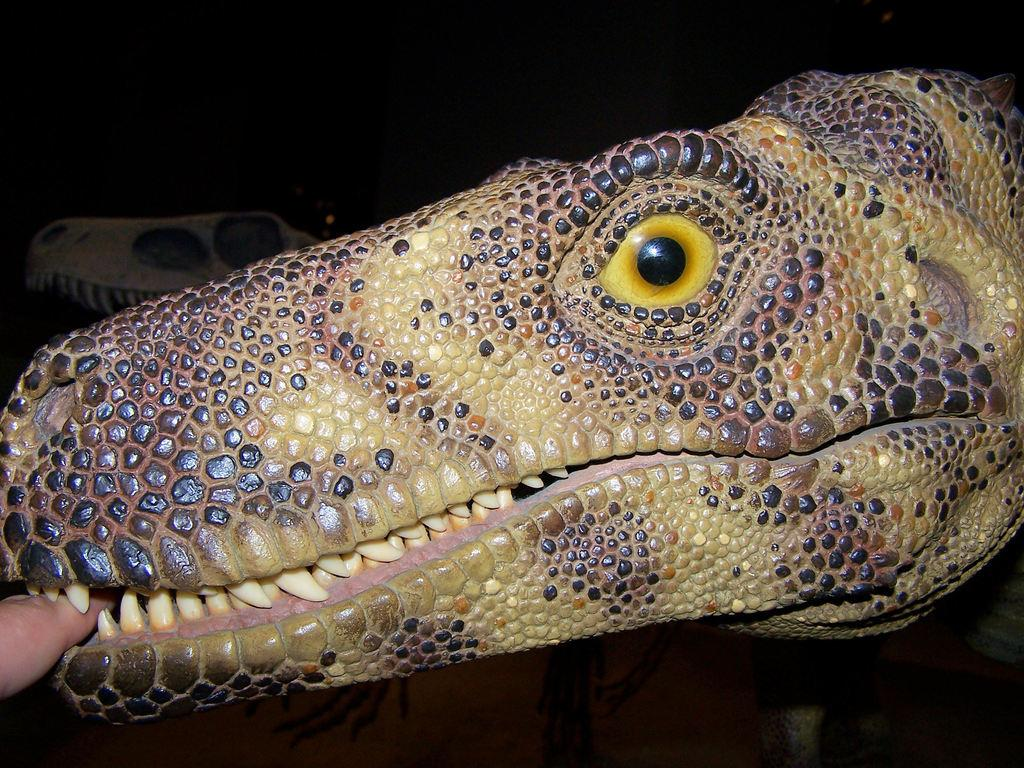What type of creatures are depicted in the image? There are two structures of dinosaurs in the image. What is the color of the background in the image? The background of the image is dark. Can you identify any human elements in the image? Yes, there is a human finger visible on the left side of the image. What type of sound can be heard coming from the dinosaurs in the image? There is no sound present in the image, as it is a static representation of dinosaur structures. 